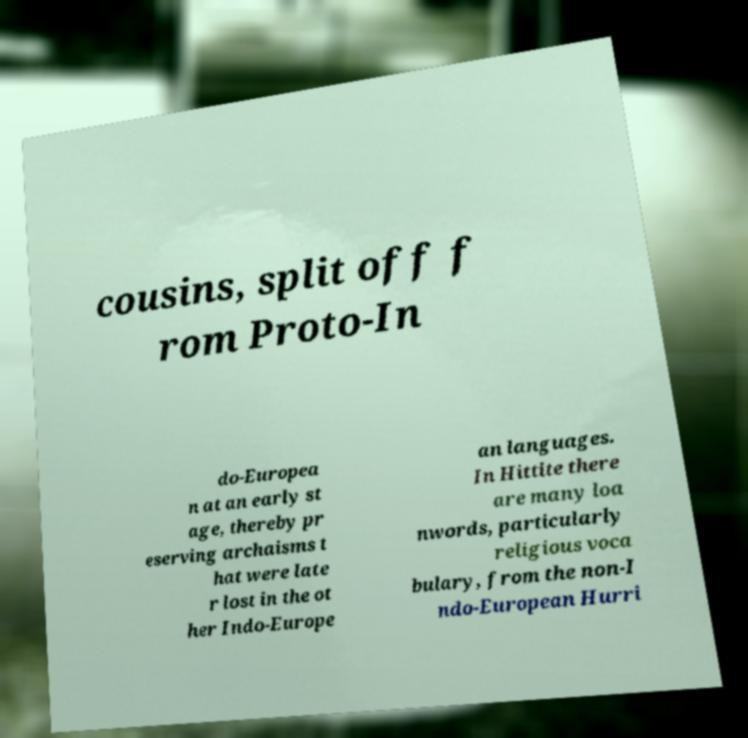Can you read and provide the text displayed in the image?This photo seems to have some interesting text. Can you extract and type it out for me? cousins, split off f rom Proto-In do-Europea n at an early st age, thereby pr eserving archaisms t hat were late r lost in the ot her Indo-Europe an languages. In Hittite there are many loa nwords, particularly religious voca bulary, from the non-I ndo-European Hurri 